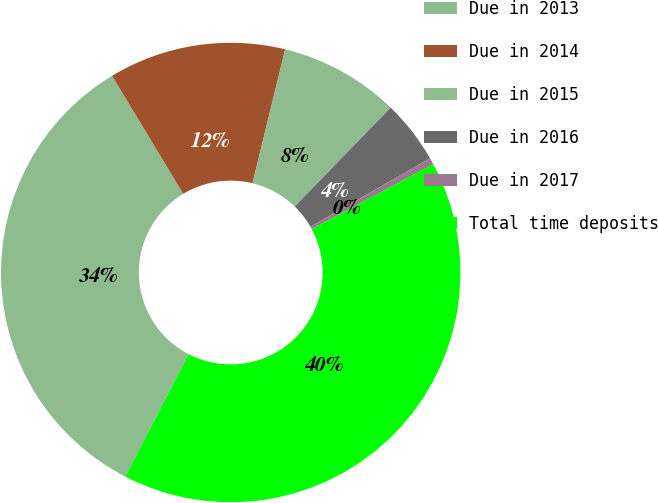Convert chart to OTSL. <chart><loc_0><loc_0><loc_500><loc_500><pie_chart><fcel>Due in 2013<fcel>Due in 2014<fcel>Due in 2015<fcel>Due in 2016<fcel>Due in 2017<fcel>Total time deposits<nl><fcel>33.77%<fcel>12.45%<fcel>8.45%<fcel>4.46%<fcel>0.47%<fcel>40.4%<nl></chart> 